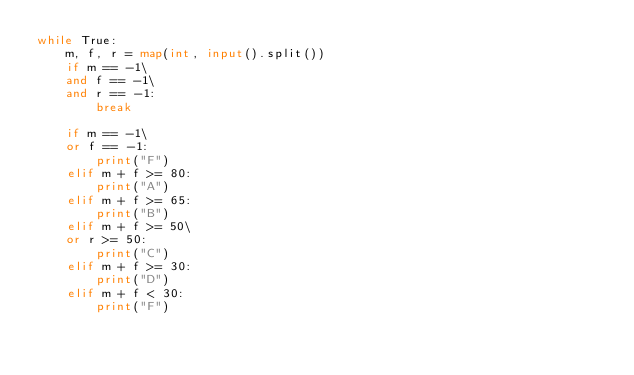Convert code to text. <code><loc_0><loc_0><loc_500><loc_500><_Python_>while True:
    m, f, r = map(int, input().split())
    if m == -1\
    and f == -1\
    and r == -1:
        break

    if m == -1\
    or f == -1:
        print("F")
    elif m + f >= 80:
        print("A")
    elif m + f >= 65:
        print("B")
    elif m + f >= 50\
    or r >= 50:
        print("C")
    elif m + f >= 30:
        print("D")
    elif m + f < 30:
        print("F")</code> 